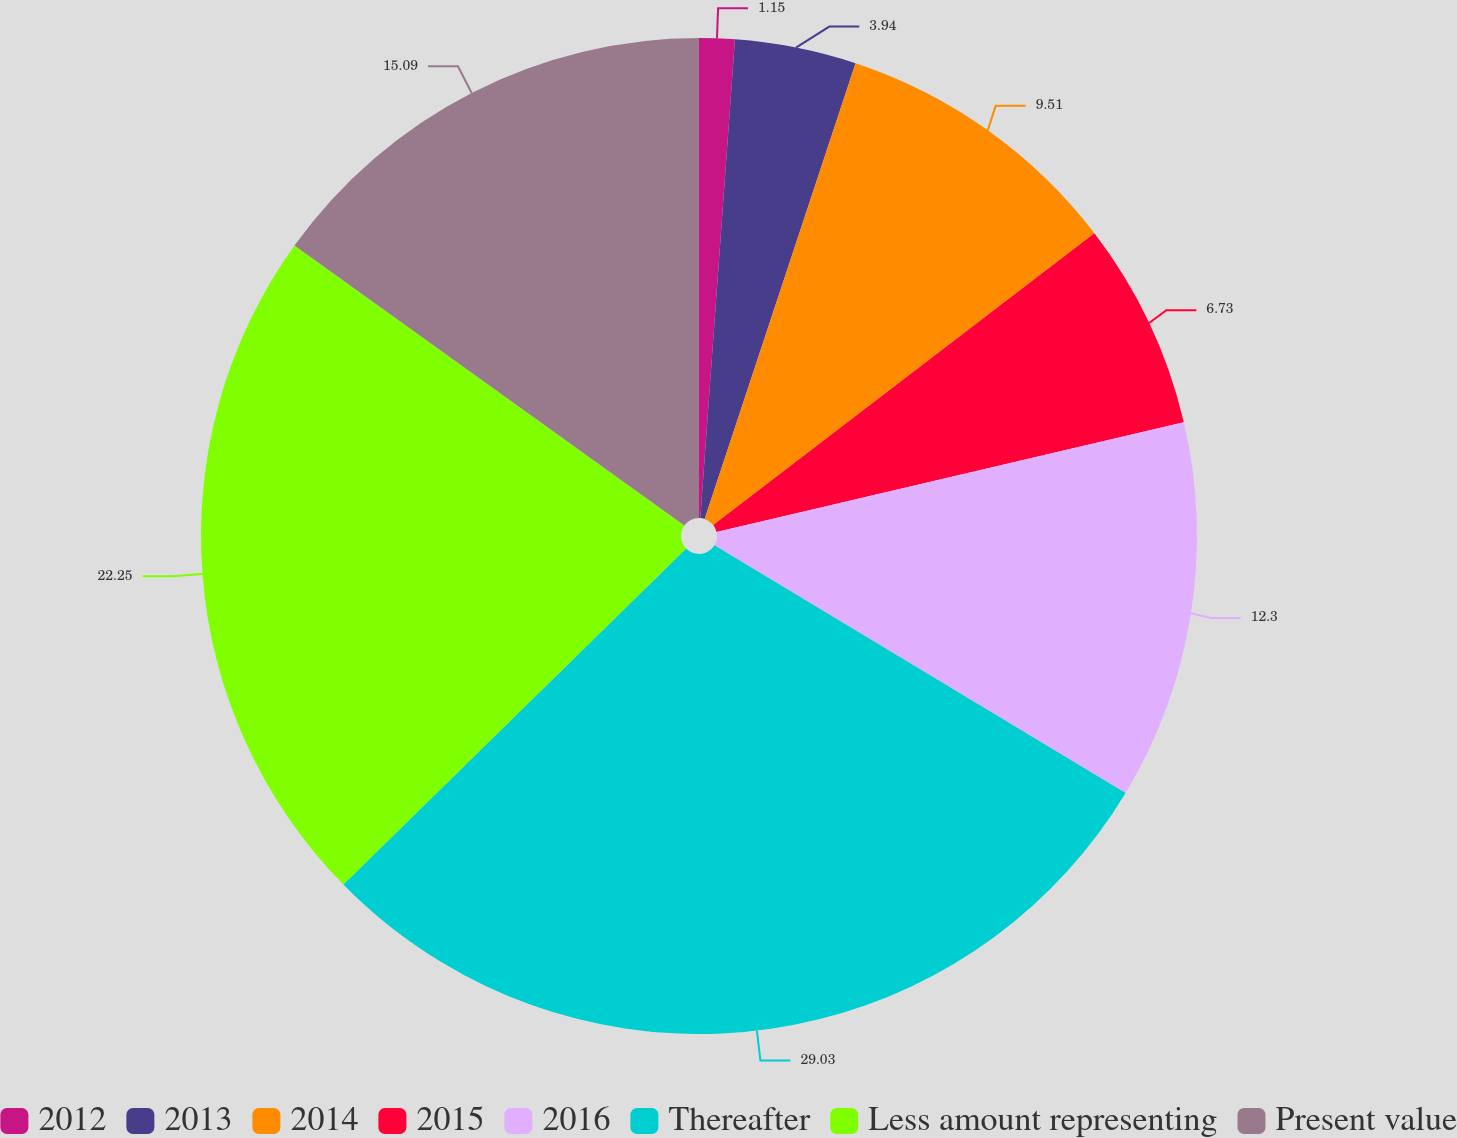Convert chart to OTSL. <chart><loc_0><loc_0><loc_500><loc_500><pie_chart><fcel>2012<fcel>2013<fcel>2014<fcel>2015<fcel>2016<fcel>Thereafter<fcel>Less amount representing<fcel>Present value<nl><fcel>1.15%<fcel>3.94%<fcel>9.51%<fcel>6.73%<fcel>12.3%<fcel>29.03%<fcel>22.25%<fcel>15.09%<nl></chart> 